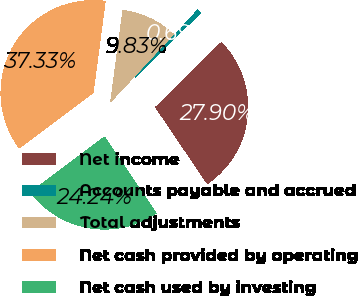Convert chart. <chart><loc_0><loc_0><loc_500><loc_500><pie_chart><fcel>Net income<fcel>Accounts payable and accrued<fcel>Total adjustments<fcel>Net cash provided by operating<fcel>Net cash used by investing<nl><fcel>27.9%<fcel>0.69%<fcel>9.83%<fcel>37.33%<fcel>24.24%<nl></chart> 